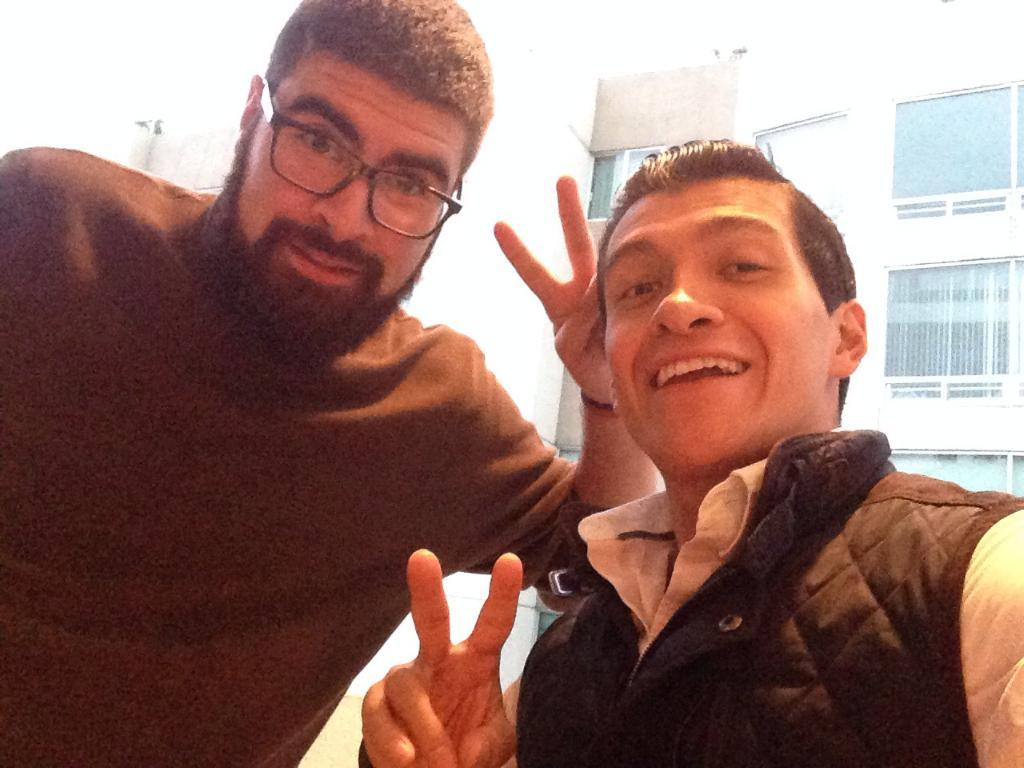How many people are in the image? There are two men in the image. What is located behind the men? There is a building behind the men. What feature can be seen on the building? There are windows on the building. What type of dress is the woman wearing in the image? There is no woman present in the image, so it is not possible to answer that question. 